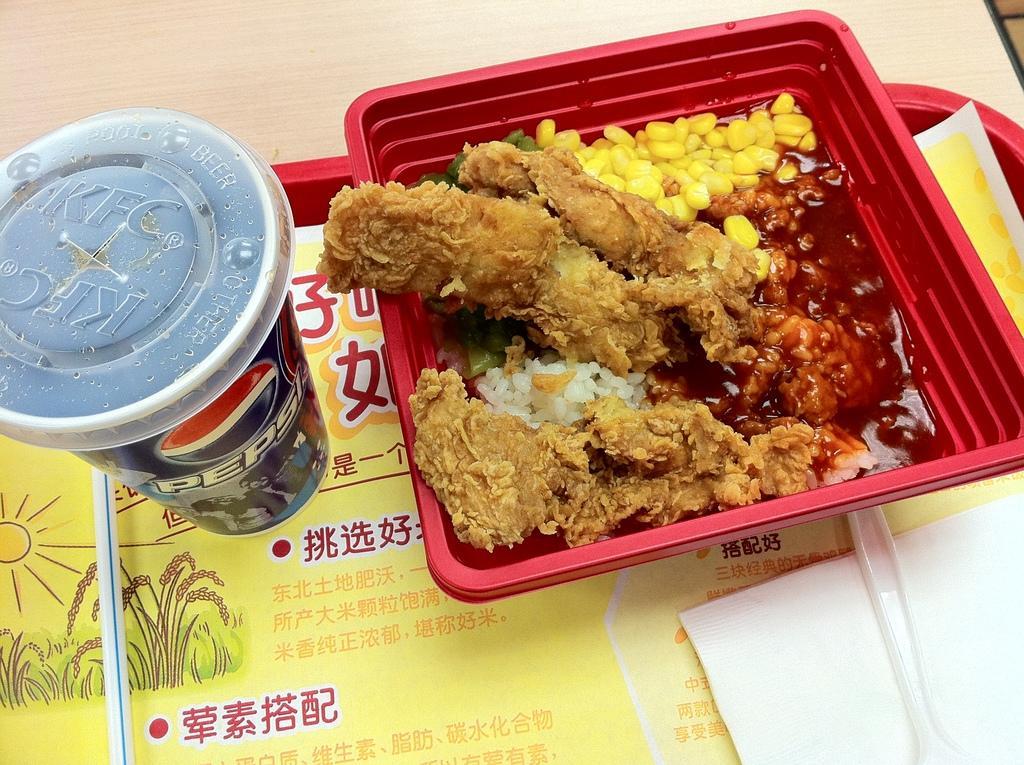Describe this image in one or two sentences. In this picture I can see there is a coke can and there is a bowl of food placed on the right side. They are placed in a tray and it is placed on the wooden table. 